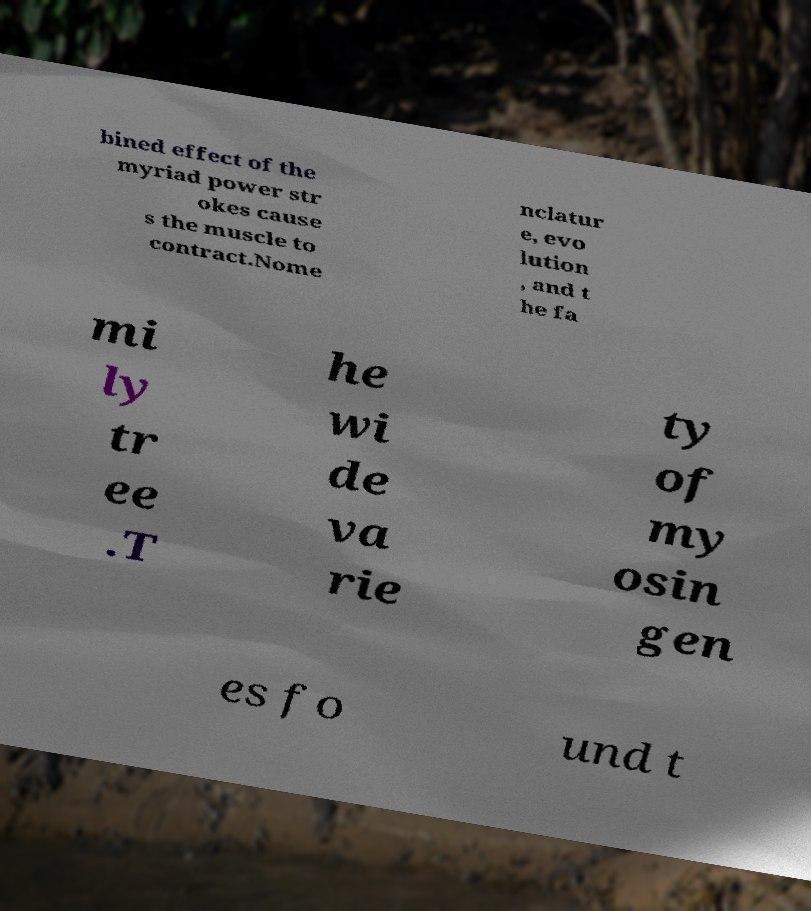Could you extract and type out the text from this image? bined effect of the myriad power str okes cause s the muscle to contract.Nome nclatur e, evo lution , and t he fa mi ly tr ee .T he wi de va rie ty of my osin gen es fo und t 